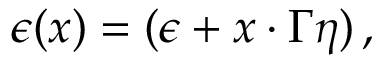<formula> <loc_0><loc_0><loc_500><loc_500>\epsilon ( x ) = ( \epsilon + x \cdot \Gamma \eta ) \, ,</formula> 